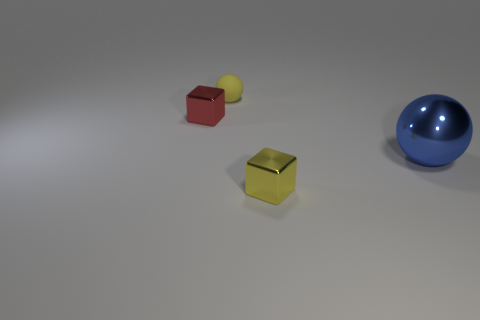Is there any other thing that has the same size as the yellow matte sphere?
Your answer should be very brief. Yes. What is the shape of the shiny thing that is the same color as the rubber object?
Provide a short and direct response. Cube. Are there fewer tiny red objects in front of the large blue metallic object than matte spheres in front of the small red metallic thing?
Your answer should be very brief. No. What number of other things are there of the same material as the small yellow ball
Give a very brief answer. 0. Does the tiny yellow block have the same material as the small red object?
Provide a short and direct response. Yes. How many other things are there of the same size as the blue metal ball?
Make the answer very short. 0. What size is the metal thing on the right side of the metallic cube that is in front of the blue object?
Give a very brief answer. Large. What color is the cube on the left side of the small cube that is on the right side of the metal thing left of the tiny matte sphere?
Offer a terse response. Red. What size is the metal thing that is both in front of the small red metal cube and left of the blue metal thing?
Offer a terse response. Small. What number of other objects are there of the same shape as the big object?
Your answer should be very brief. 1. 